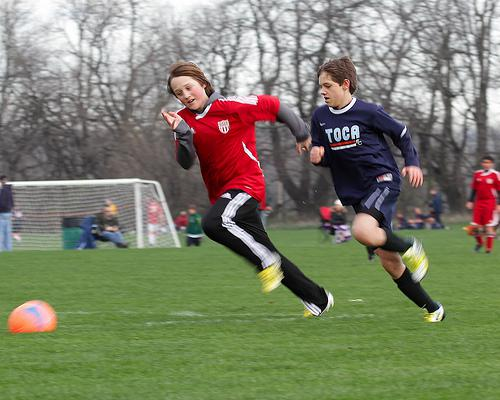Question: what color is the ball?
Choices:
A. Blue.
B. Red.
C. Teal.
D. Orange.
Answer with the letter. Answer: D Question: what is yellow?
Choices:
A. The dandelion.
B. The house.
C. The car.
D. The boys sneakers.
Answer with the letter. Answer: D Question: what is on the ground?
Choices:
A. Grass.
B. Dirt.
C. A plant.
D. A shoe.
Answer with the letter. Answer: A 